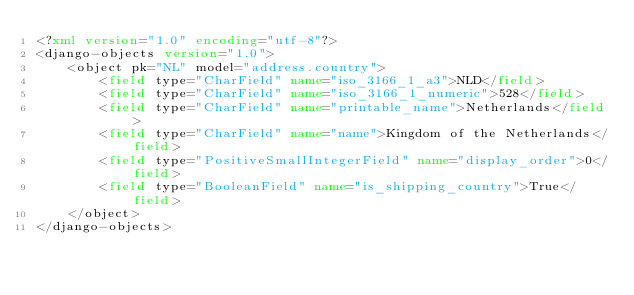<code> <loc_0><loc_0><loc_500><loc_500><_XML_><?xml version="1.0" encoding="utf-8"?>
<django-objects version="1.0">
    <object pk="NL" model="address.country">
        <field type="CharField" name="iso_3166_1_a3">NLD</field>
        <field type="CharField" name="iso_3166_1_numeric">528</field>
        <field type="CharField" name="printable_name">Netherlands</field>
        <field type="CharField" name="name">Kingdom of the Netherlands</field>
        <field type="PositiveSmallIntegerField" name="display_order">0</field>
        <field type="BooleanField" name="is_shipping_country">True</field>
    </object>
</django-objects>
</code> 